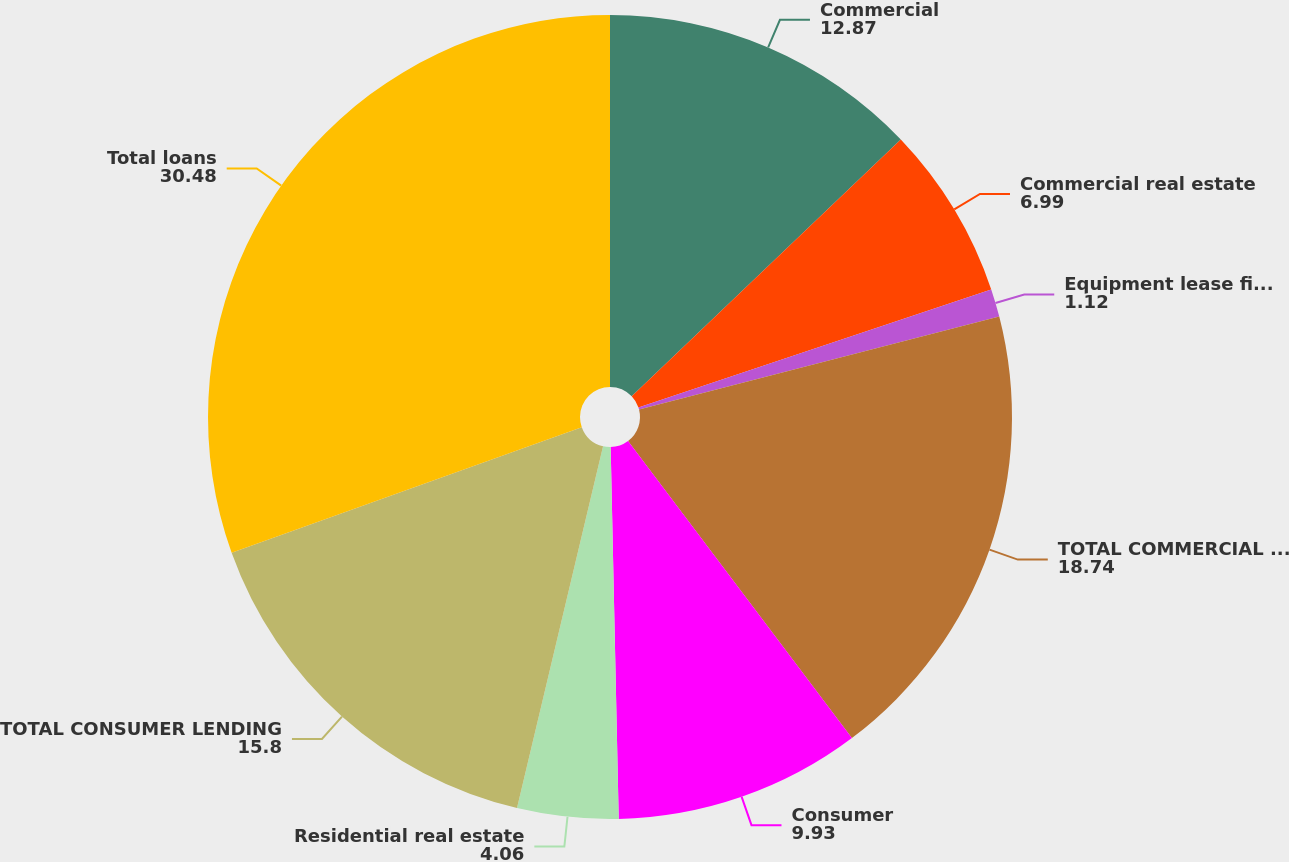Convert chart to OTSL. <chart><loc_0><loc_0><loc_500><loc_500><pie_chart><fcel>Commercial<fcel>Commercial real estate<fcel>Equipment lease financing<fcel>TOTAL COMMERCIAL LENDING<fcel>Consumer<fcel>Residential real estate<fcel>TOTAL CONSUMER LENDING<fcel>Total loans<nl><fcel>12.87%<fcel>6.99%<fcel>1.12%<fcel>18.74%<fcel>9.93%<fcel>4.06%<fcel>15.8%<fcel>30.48%<nl></chart> 